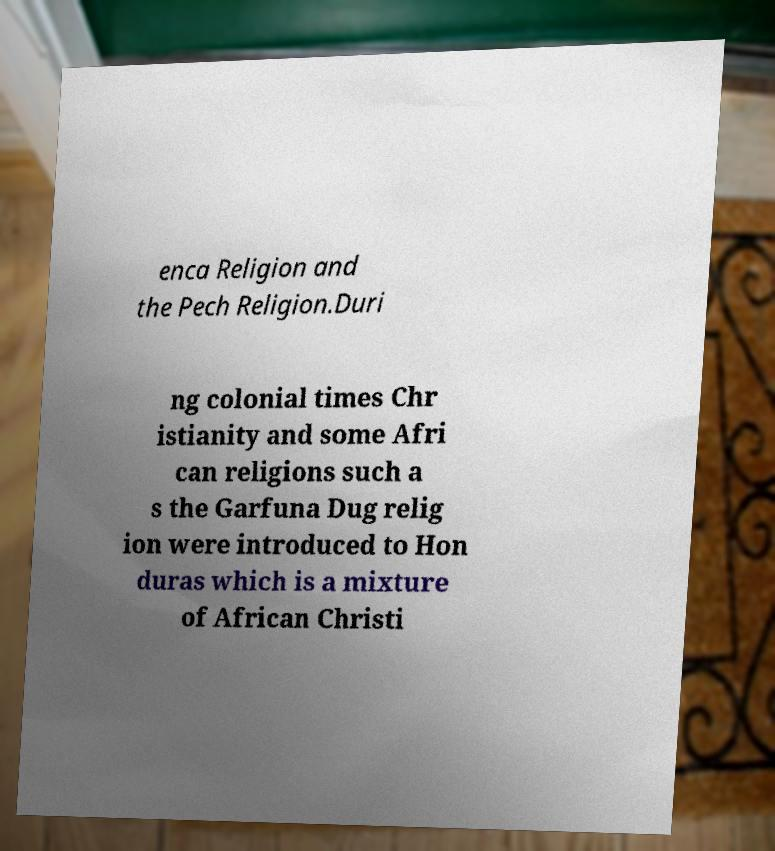Please read and relay the text visible in this image. What does it say? enca Religion and the Pech Religion.Duri ng colonial times Chr istianity and some Afri can religions such a s the Garfuna Dug relig ion were introduced to Hon duras which is a mixture of African Christi 